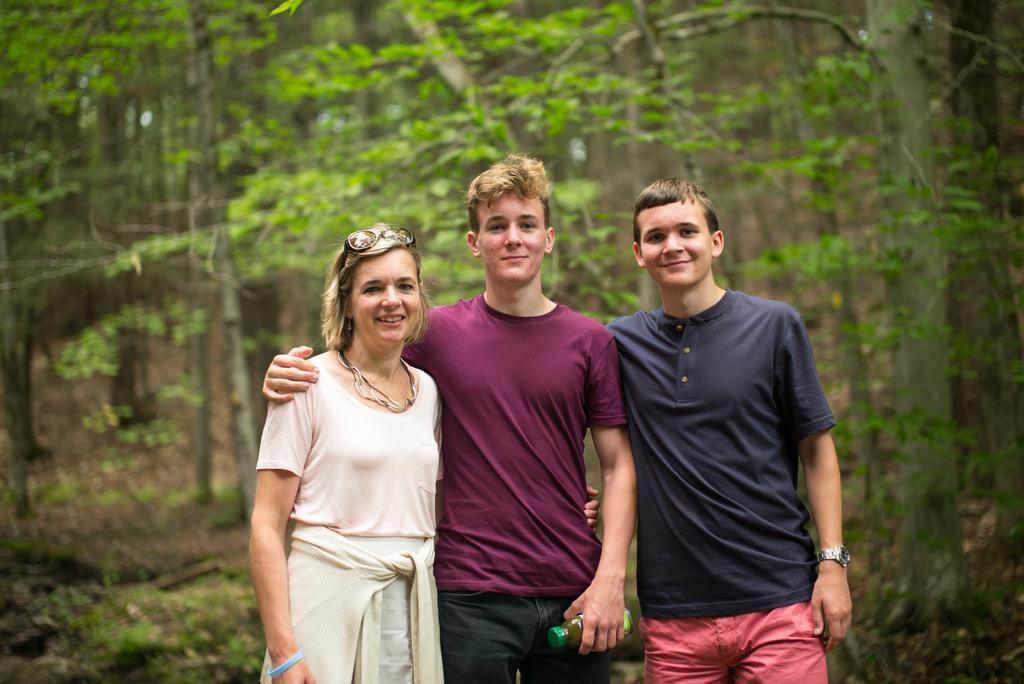Describe this image in one or two sentences. In this image I can see three persons standing. The person at right wearing blue shirt, red short, the person in the middle wearing maroon shirt and the person at left wearing white dress. Background I can see trees in green color. 